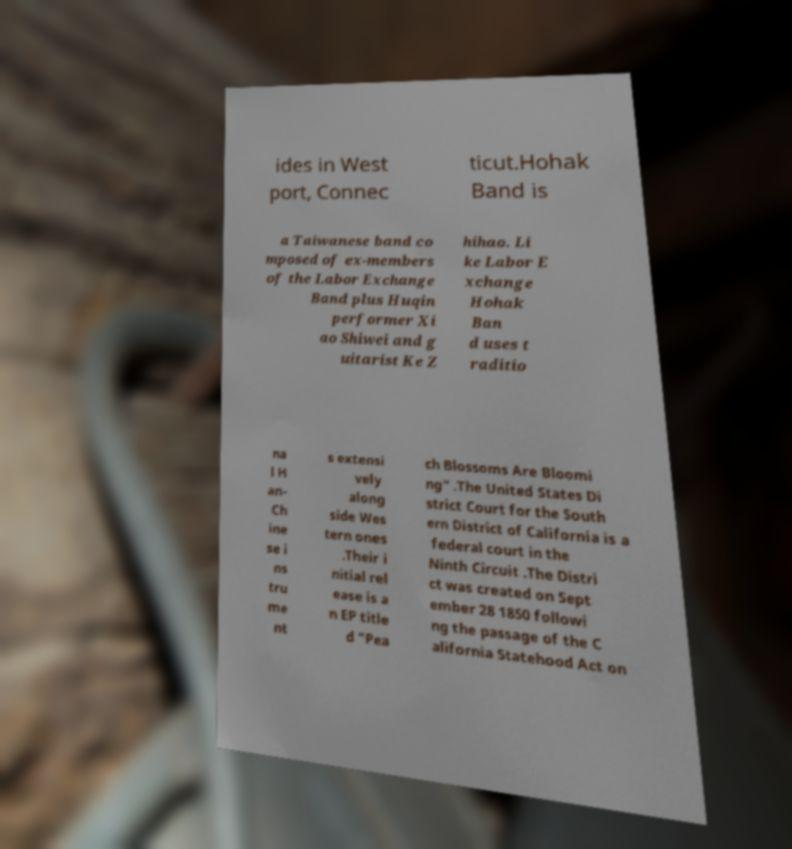For documentation purposes, I need the text within this image transcribed. Could you provide that? ides in West port, Connec ticut.Hohak Band is a Taiwanese band co mposed of ex-members of the Labor Exchange Band plus Huqin performer Xi ao Shiwei and g uitarist Ke Z hihao. Li ke Labor E xchange Hohak Ban d uses t raditio na l H an- Ch ine se i ns tru me nt s extensi vely along side Wes tern ones .Their i nitial rel ease is a n EP title d "Pea ch Blossoms Are Bloomi ng" .The United States Di strict Court for the South ern District of California is a federal court in the Ninth Circuit .The Distri ct was created on Sept ember 28 1850 followi ng the passage of the C alifornia Statehood Act on 